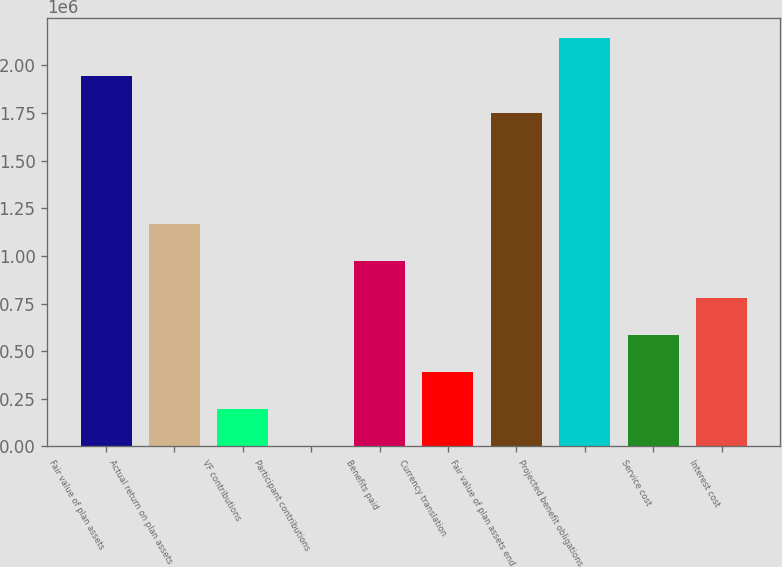Convert chart to OTSL. <chart><loc_0><loc_0><loc_500><loc_500><bar_chart><fcel>Fair value of plan assets<fcel>Actual return on plan assets<fcel>VF contributions<fcel>Participant contributions<fcel>Benefits paid<fcel>Currency translation<fcel>Fair value of plan assets end<fcel>Projected benefit obligations<fcel>Service cost<fcel>Interest cost<nl><fcel>1.94604e+06<fcel>1.1667e+06<fcel>195298<fcel>1018<fcel>972420<fcel>389579<fcel>1.75176e+06<fcel>2.14032e+06<fcel>583859<fcel>778139<nl></chart> 